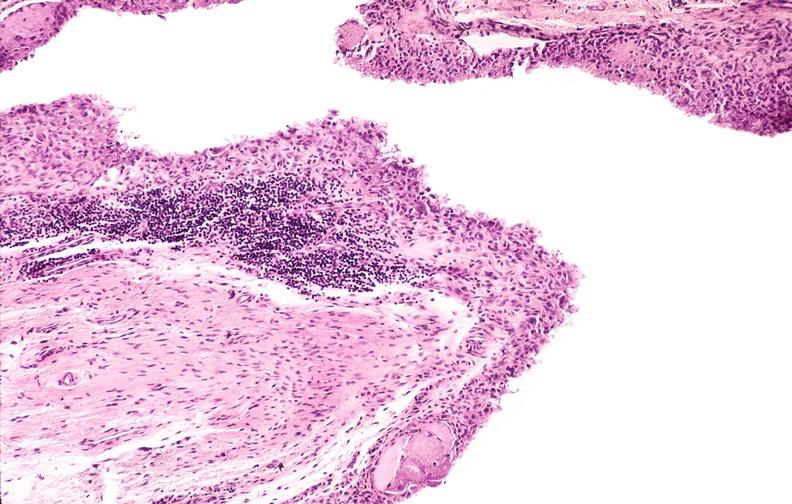what does this image show?
Answer the question using a single word or phrase. Rheumatoid arthritis 